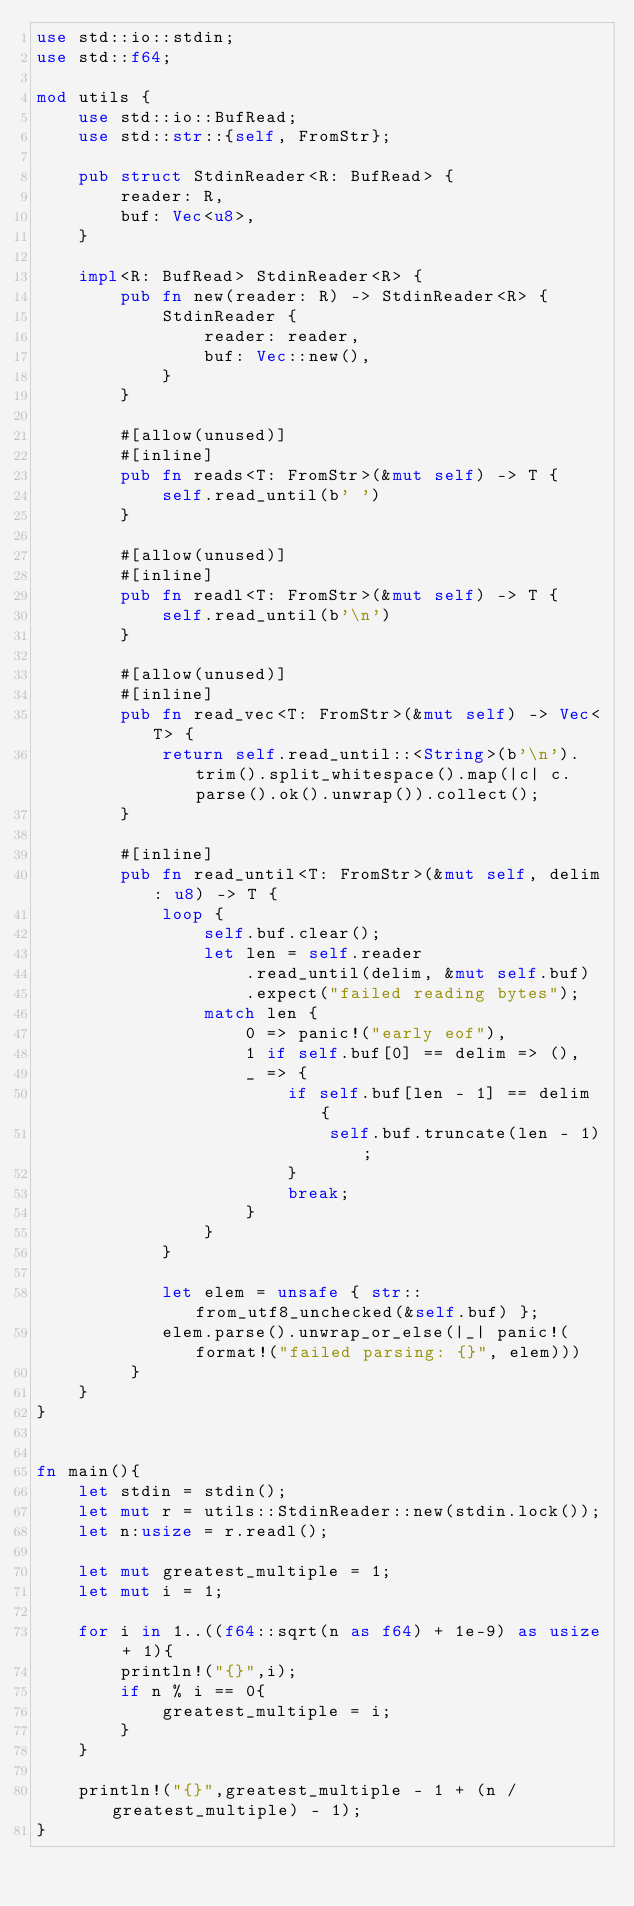<code> <loc_0><loc_0><loc_500><loc_500><_Rust_>use std::io::stdin;
use std::f64;

mod utils {
    use std::io::BufRead;
    use std::str::{self, FromStr};

    pub struct StdinReader<R: BufRead> {
        reader: R,
        buf: Vec<u8>,
    }

    impl<R: BufRead> StdinReader<R> {
        pub fn new(reader: R) -> StdinReader<R> {
            StdinReader {
                reader: reader,
                buf: Vec::new(),
            }
        }

        #[allow(unused)]
        #[inline]
        pub fn reads<T: FromStr>(&mut self) -> T {
            self.read_until(b' ')
        }

        #[allow(unused)]
        #[inline]
        pub fn readl<T: FromStr>(&mut self) -> T {
            self.read_until(b'\n')
        }

        #[allow(unused)]
        #[inline]
        pub fn read_vec<T: FromStr>(&mut self) -> Vec<T> {
            return self.read_until::<String>(b'\n').trim().split_whitespace().map(|c| c.parse().ok().unwrap()).collect();
        }

        #[inline]
        pub fn read_until<T: FromStr>(&mut self, delim: u8) -> T {
            loop {
                self.buf.clear();
                let len = self.reader
                    .read_until(delim, &mut self.buf)
                    .expect("failed reading bytes");
                match len {
                    0 => panic!("early eof"),
                    1 if self.buf[0] == delim => (),
                    _ => {
                        if self.buf[len - 1] == delim {
                            self.buf.truncate(len - 1);
                        }
                        break;
                    }
                }
            }

            let elem = unsafe { str::from_utf8_unchecked(&self.buf) };
            elem.parse().unwrap_or_else(|_| panic!(format!("failed parsing: {}", elem)))
         }
    }
}


fn main(){
    let stdin = stdin();
    let mut r = utils::StdinReader::new(stdin.lock());
    let n:usize = r.readl();

    let mut greatest_multiple = 1;
    let mut i = 1;

    for i in 1..((f64::sqrt(n as f64) + 1e-9) as usize + 1){
        println!("{}",i);
        if n % i == 0{
            greatest_multiple = i;
        }
    }

    println!("{}",greatest_multiple - 1 + (n / greatest_multiple) - 1);
}
</code> 